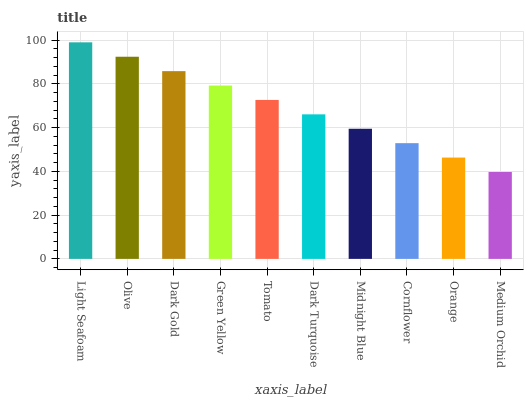Is Medium Orchid the minimum?
Answer yes or no. Yes. Is Light Seafoam the maximum?
Answer yes or no. Yes. Is Olive the minimum?
Answer yes or no. No. Is Olive the maximum?
Answer yes or no. No. Is Light Seafoam greater than Olive?
Answer yes or no. Yes. Is Olive less than Light Seafoam?
Answer yes or no. Yes. Is Olive greater than Light Seafoam?
Answer yes or no. No. Is Light Seafoam less than Olive?
Answer yes or no. No. Is Tomato the high median?
Answer yes or no. Yes. Is Dark Turquoise the low median?
Answer yes or no. Yes. Is Dark Turquoise the high median?
Answer yes or no. No. Is Green Yellow the low median?
Answer yes or no. No. 